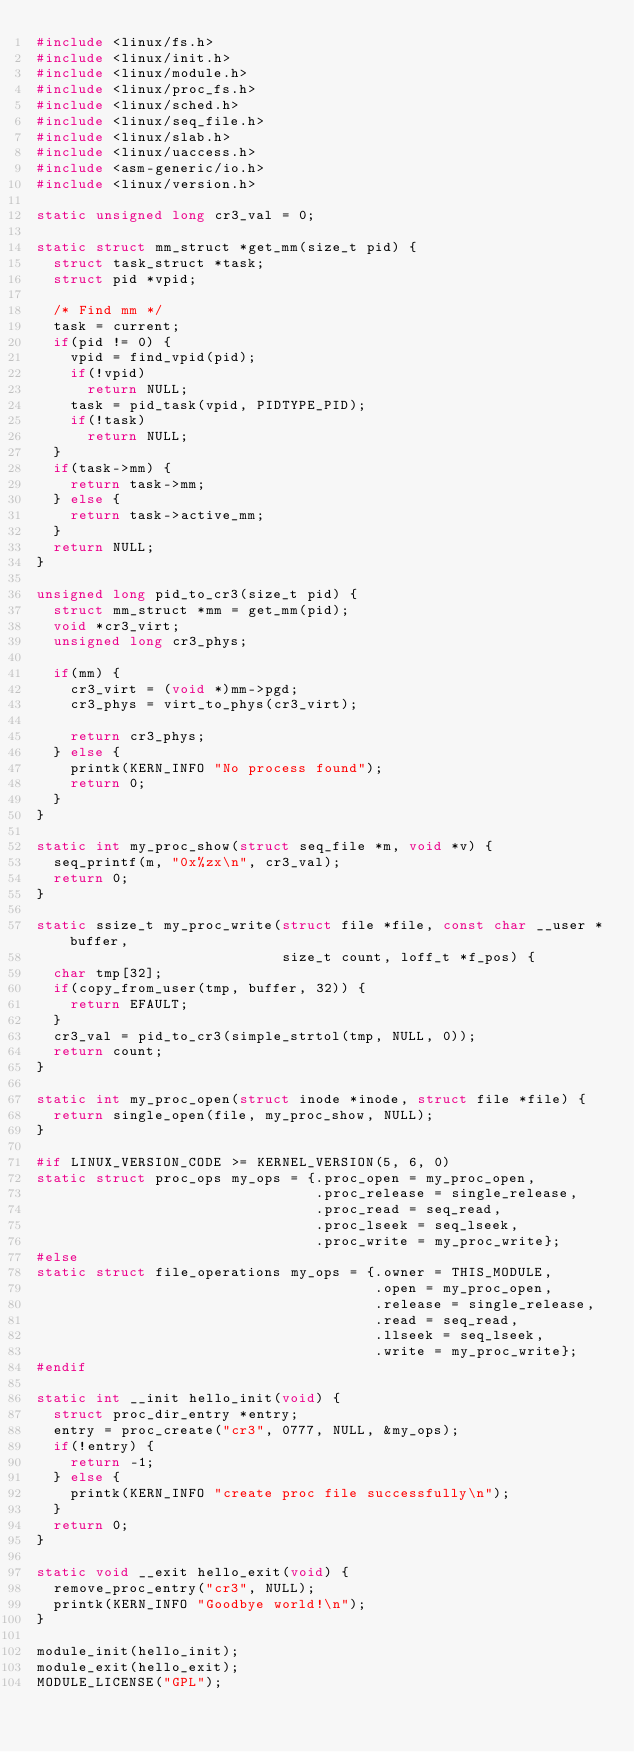<code> <loc_0><loc_0><loc_500><loc_500><_C_>#include <linux/fs.h>
#include <linux/init.h>
#include <linux/module.h>
#include <linux/proc_fs.h>
#include <linux/sched.h>
#include <linux/seq_file.h>
#include <linux/slab.h>
#include <linux/uaccess.h>
#include <asm-generic/io.h>
#include <linux/version.h>

static unsigned long cr3_val = 0;

static struct mm_struct *get_mm(size_t pid) {
  struct task_struct *task;
  struct pid *vpid;

  /* Find mm */
  task = current;
  if(pid != 0) {
    vpid = find_vpid(pid);
    if(!vpid)
      return NULL;
    task = pid_task(vpid, PIDTYPE_PID);
    if(!task)
      return NULL;
  }
  if(task->mm) {
    return task->mm;
  } else {
    return task->active_mm;
  }
  return NULL;
}

unsigned long pid_to_cr3(size_t pid) {
  struct mm_struct *mm = get_mm(pid);
  void *cr3_virt;
  unsigned long cr3_phys;

  if(mm) {
    cr3_virt = (void *)mm->pgd;
    cr3_phys = virt_to_phys(cr3_virt);

    return cr3_phys;
  } else {
    printk(KERN_INFO "No process found");
    return 0;
  }
}

static int my_proc_show(struct seq_file *m, void *v) {
  seq_printf(m, "0x%zx\n", cr3_val);
  return 0;
}

static ssize_t my_proc_write(struct file *file, const char __user *buffer,
                             size_t count, loff_t *f_pos) {
  char tmp[32];
  if(copy_from_user(tmp, buffer, 32)) {
    return EFAULT;
  }
  cr3_val = pid_to_cr3(simple_strtol(tmp, NULL, 0));
  return count;
}

static int my_proc_open(struct inode *inode, struct file *file) {
  return single_open(file, my_proc_show, NULL);
}

#if LINUX_VERSION_CODE >= KERNEL_VERSION(5, 6, 0)
static struct proc_ops my_ops = {.proc_open = my_proc_open,
                                 .proc_release = single_release,
                                 .proc_read = seq_read,
                                 .proc_lseek = seq_lseek,
                                 .proc_write = my_proc_write};
#else
static struct file_operations my_ops = {.owner = THIS_MODULE,
                                        .open = my_proc_open,
                                        .release = single_release,
                                        .read = seq_read,
                                        .llseek = seq_lseek,
                                        .write = my_proc_write};
#endif

static int __init hello_init(void) {
  struct proc_dir_entry *entry;
  entry = proc_create("cr3", 0777, NULL, &my_ops);
  if(!entry) {
    return -1;
  } else {
    printk(KERN_INFO "create proc file successfully\n");
  }
  return 0;
}

static void __exit hello_exit(void) {
  remove_proc_entry("cr3", NULL);
  printk(KERN_INFO "Goodbye world!\n");
}

module_init(hello_init);
module_exit(hello_exit);
MODULE_LICENSE("GPL");
</code> 